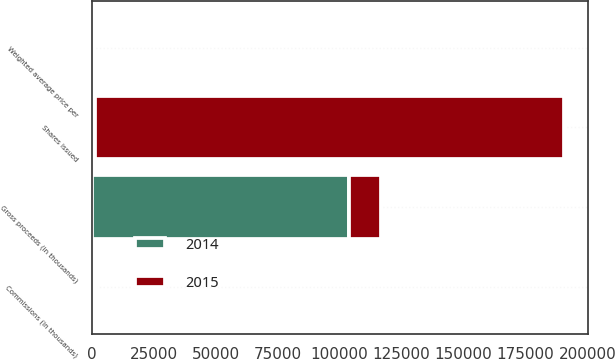Convert chart. <chart><loc_0><loc_0><loc_500><loc_500><stacked_bar_chart><ecel><fcel>Shares issued<fcel>Weighted average price per<fcel>Gross proceeds (in thousands)<fcel>Commissions (in thousands)<nl><fcel>2015<fcel>189266<fcel>67.86<fcel>12843<fcel>161<nl><fcel>2014<fcel>1369<fcel>60<fcel>103821<fcel>1369<nl></chart> 